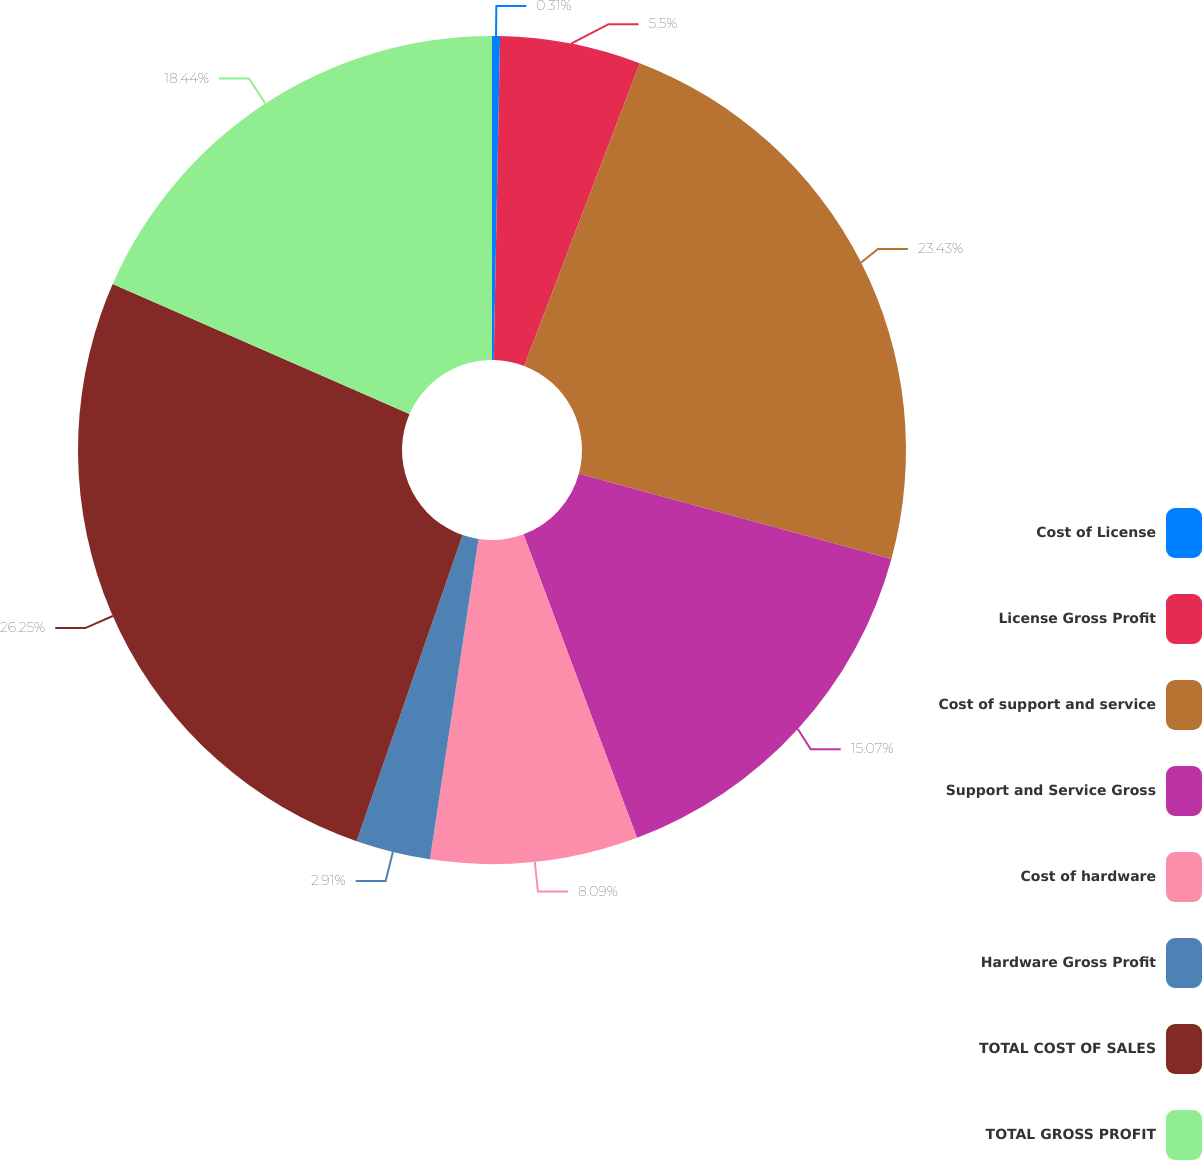Convert chart. <chart><loc_0><loc_0><loc_500><loc_500><pie_chart><fcel>Cost of License<fcel>License Gross Profit<fcel>Cost of support and service<fcel>Support and Service Gross<fcel>Cost of hardware<fcel>Hardware Gross Profit<fcel>TOTAL COST OF SALES<fcel>TOTAL GROSS PROFIT<nl><fcel>0.31%<fcel>5.5%<fcel>23.43%<fcel>15.07%<fcel>8.09%<fcel>2.91%<fcel>26.26%<fcel>18.44%<nl></chart> 